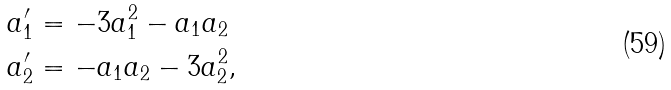<formula> <loc_0><loc_0><loc_500><loc_500>a _ { 1 } ^ { \prime } & = - 3 a _ { 1 } ^ { 2 } - a _ { 1 } a _ { 2 } \\ a _ { 2 } ^ { \prime } & = - a _ { 1 } a _ { 2 } - 3 a _ { 2 } ^ { 2 } ,</formula> 